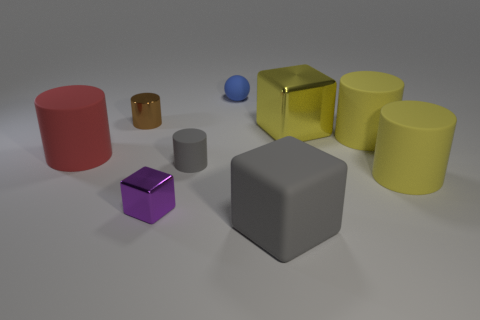Subtract 2 cylinders. How many cylinders are left? 3 Subtract all red rubber cylinders. How many cylinders are left? 4 Subtract all gray cylinders. How many cylinders are left? 4 Subtract all cyan cylinders. Subtract all red cubes. How many cylinders are left? 5 Add 1 big cyan cylinders. How many objects exist? 10 Subtract all cubes. How many objects are left? 6 Subtract 1 red cylinders. How many objects are left? 8 Subtract all large metallic blocks. Subtract all small metallic cylinders. How many objects are left? 7 Add 3 brown metal objects. How many brown metal objects are left? 4 Add 9 tiny metallic cylinders. How many tiny metallic cylinders exist? 10 